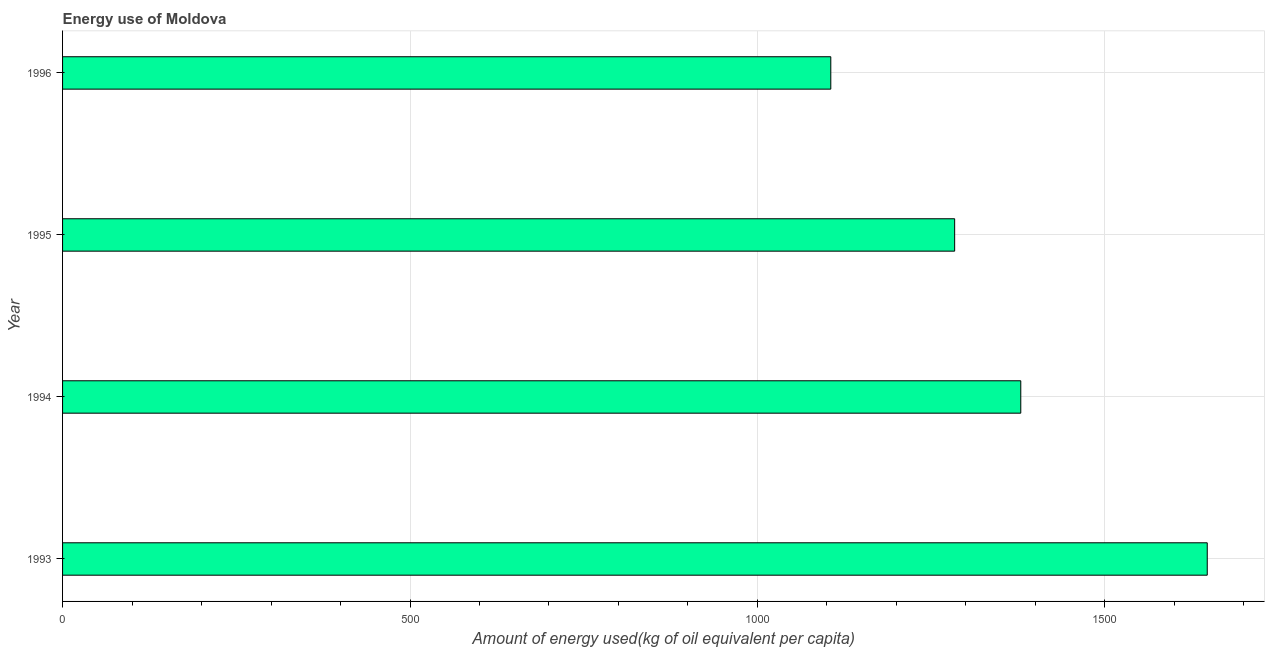Does the graph contain any zero values?
Keep it short and to the point. No. What is the title of the graph?
Give a very brief answer. Energy use of Moldova. What is the label or title of the X-axis?
Your response must be concise. Amount of energy used(kg of oil equivalent per capita). What is the label or title of the Y-axis?
Make the answer very short. Year. What is the amount of energy used in 1995?
Your answer should be compact. 1283.8. Across all years, what is the maximum amount of energy used?
Give a very brief answer. 1647.32. Across all years, what is the minimum amount of energy used?
Offer a very short reply. 1105.57. What is the sum of the amount of energy used?
Your answer should be compact. 5415.66. What is the difference between the amount of energy used in 1994 and 1995?
Keep it short and to the point. 95.17. What is the average amount of energy used per year?
Keep it short and to the point. 1353.91. What is the median amount of energy used?
Offer a very short reply. 1331.38. In how many years, is the amount of energy used greater than 500 kg?
Your response must be concise. 4. Do a majority of the years between 1993 and 1995 (inclusive) have amount of energy used greater than 1100 kg?
Your response must be concise. Yes. What is the ratio of the amount of energy used in 1993 to that in 1996?
Your response must be concise. 1.49. Is the amount of energy used in 1993 less than that in 1995?
Your answer should be very brief. No. What is the difference between the highest and the second highest amount of energy used?
Provide a succinct answer. 268.35. Is the sum of the amount of energy used in 1994 and 1995 greater than the maximum amount of energy used across all years?
Offer a terse response. Yes. What is the difference between the highest and the lowest amount of energy used?
Give a very brief answer. 541.75. How many bars are there?
Your response must be concise. 4. What is the difference between two consecutive major ticks on the X-axis?
Give a very brief answer. 500. What is the Amount of energy used(kg of oil equivalent per capita) of 1993?
Keep it short and to the point. 1647.32. What is the Amount of energy used(kg of oil equivalent per capita) of 1994?
Make the answer very short. 1378.97. What is the Amount of energy used(kg of oil equivalent per capita) of 1995?
Keep it short and to the point. 1283.8. What is the Amount of energy used(kg of oil equivalent per capita) in 1996?
Your answer should be very brief. 1105.57. What is the difference between the Amount of energy used(kg of oil equivalent per capita) in 1993 and 1994?
Offer a terse response. 268.35. What is the difference between the Amount of energy used(kg of oil equivalent per capita) in 1993 and 1995?
Your answer should be compact. 363.52. What is the difference between the Amount of energy used(kg of oil equivalent per capita) in 1993 and 1996?
Offer a terse response. 541.75. What is the difference between the Amount of energy used(kg of oil equivalent per capita) in 1994 and 1995?
Your answer should be very brief. 95.17. What is the difference between the Amount of energy used(kg of oil equivalent per capita) in 1994 and 1996?
Keep it short and to the point. 273.4. What is the difference between the Amount of energy used(kg of oil equivalent per capita) in 1995 and 1996?
Your answer should be compact. 178.23. What is the ratio of the Amount of energy used(kg of oil equivalent per capita) in 1993 to that in 1994?
Offer a very short reply. 1.2. What is the ratio of the Amount of energy used(kg of oil equivalent per capita) in 1993 to that in 1995?
Provide a succinct answer. 1.28. What is the ratio of the Amount of energy used(kg of oil equivalent per capita) in 1993 to that in 1996?
Provide a short and direct response. 1.49. What is the ratio of the Amount of energy used(kg of oil equivalent per capita) in 1994 to that in 1995?
Provide a succinct answer. 1.07. What is the ratio of the Amount of energy used(kg of oil equivalent per capita) in 1994 to that in 1996?
Your response must be concise. 1.25. What is the ratio of the Amount of energy used(kg of oil equivalent per capita) in 1995 to that in 1996?
Offer a terse response. 1.16. 